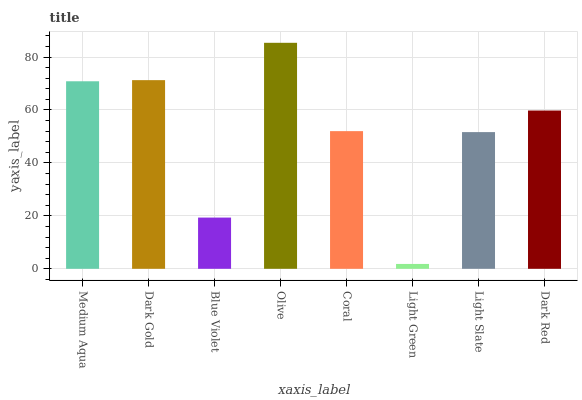Is Light Green the minimum?
Answer yes or no. Yes. Is Olive the maximum?
Answer yes or no. Yes. Is Dark Gold the minimum?
Answer yes or no. No. Is Dark Gold the maximum?
Answer yes or no. No. Is Dark Gold greater than Medium Aqua?
Answer yes or no. Yes. Is Medium Aqua less than Dark Gold?
Answer yes or no. Yes. Is Medium Aqua greater than Dark Gold?
Answer yes or no. No. Is Dark Gold less than Medium Aqua?
Answer yes or no. No. Is Dark Red the high median?
Answer yes or no. Yes. Is Coral the low median?
Answer yes or no. Yes. Is Olive the high median?
Answer yes or no. No. Is Light Green the low median?
Answer yes or no. No. 